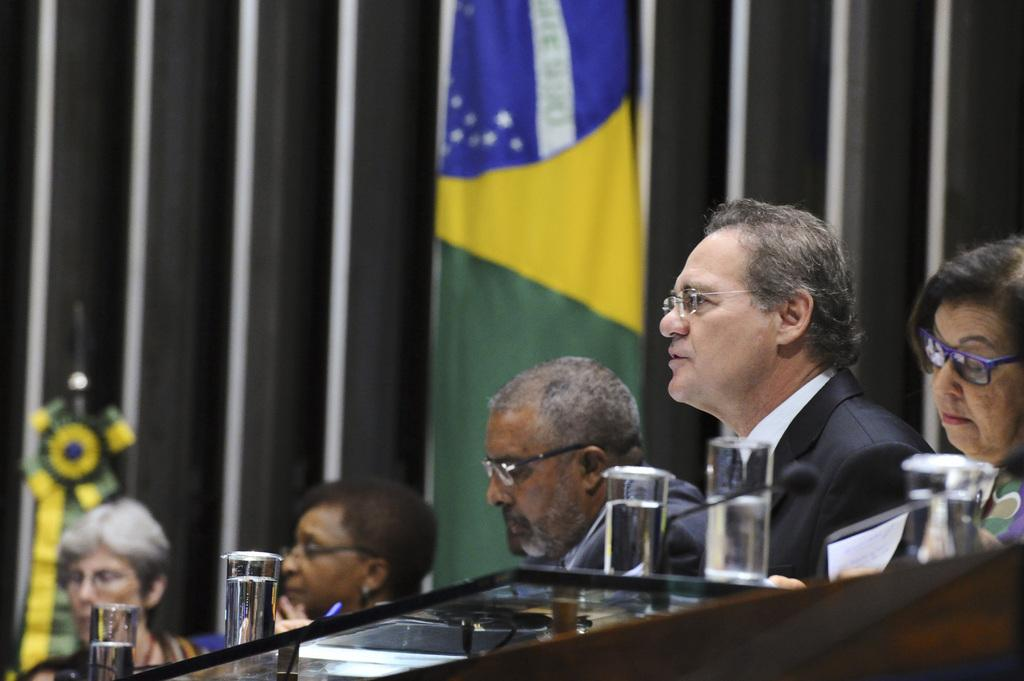Who or what is in the image? There are people in the image. What is the people interacting with or near in the image? There is a table in the image, and glasses are present on the table. What is the flag's location in the image? There is a flag in the image. Can you describe the object on the left side of the image? There is an object on the left side of the image, but its specific details are not mentioned in the facts. What can be seen in the background of the image? There is a wall in the background of the image. Where is the toothbrush located in the image? There is no toothbrush present in the image. What type of linen is draped over the table in the image? There is no linen mentioned or visible in the image. 